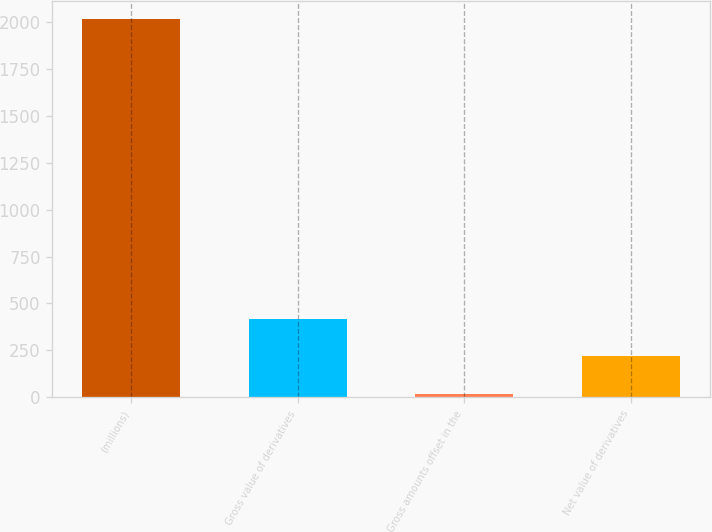Convert chart. <chart><loc_0><loc_0><loc_500><loc_500><bar_chart><fcel>(millions)<fcel>Gross value of derivatives<fcel>Gross amounts offset in the<fcel>Net value of derivatives<nl><fcel>2014<fcel>417.28<fcel>18.1<fcel>217.69<nl></chart> 